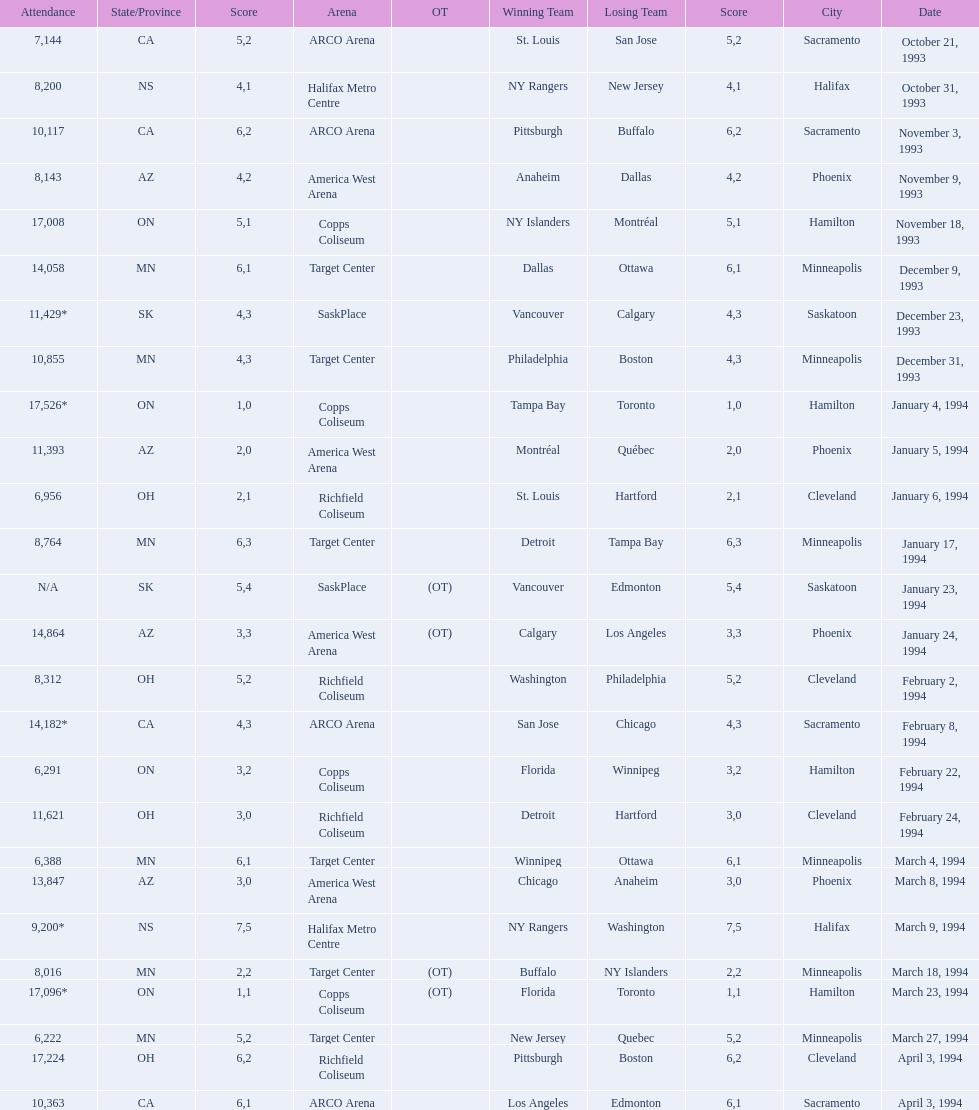Could you help me parse every detail presented in this table? {'header': ['Attendance', 'State/Province', 'Score', 'Arena', 'OT', 'Winning Team', 'Losing Team', 'Score', 'City', 'Date'], 'rows': [['7,144', 'CA', '5', 'ARCO Arena', '', 'St. Louis', 'San Jose', '2', 'Sacramento', 'October 21, 1993'], ['8,200', 'NS', '4', 'Halifax Metro Centre', '', 'NY Rangers', 'New Jersey', '1', 'Halifax', 'October 31, 1993'], ['10,117', 'CA', '6', 'ARCO Arena', '', 'Pittsburgh', 'Buffalo', '2', 'Sacramento', 'November 3, 1993'], ['8,143', 'AZ', '4', 'America West Arena', '', 'Anaheim', 'Dallas', '2', 'Phoenix', 'November 9, 1993'], ['17,008', 'ON', '5', 'Copps Coliseum', '', 'NY Islanders', 'Montréal', '1', 'Hamilton', 'November 18, 1993'], ['14,058', 'MN', '6', 'Target Center', '', 'Dallas', 'Ottawa', '1', 'Minneapolis', 'December 9, 1993'], ['11,429*', 'SK', '4', 'SaskPlace', '', 'Vancouver', 'Calgary', '3', 'Saskatoon', 'December 23, 1993'], ['10,855', 'MN', '4', 'Target Center', '', 'Philadelphia', 'Boston', '3', 'Minneapolis', 'December 31, 1993'], ['17,526*', 'ON', '1', 'Copps Coliseum', '', 'Tampa Bay', 'Toronto', '0', 'Hamilton', 'January 4, 1994'], ['11,393', 'AZ', '2', 'America West Arena', '', 'Montréal', 'Québec', '0', 'Phoenix', 'January 5, 1994'], ['6,956', 'OH', '2', 'Richfield Coliseum', '', 'St. Louis', 'Hartford', '1', 'Cleveland', 'January 6, 1994'], ['8,764', 'MN', '6', 'Target Center', '', 'Detroit', 'Tampa Bay', '3', 'Minneapolis', 'January 17, 1994'], ['N/A', 'SK', '5', 'SaskPlace', '(OT)', 'Vancouver', 'Edmonton', '4', 'Saskatoon', 'January 23, 1994'], ['14,864', 'AZ', '3', 'America West Arena', '(OT)', 'Calgary', 'Los Angeles', '3', 'Phoenix', 'January 24, 1994'], ['8,312', 'OH', '5', 'Richfield Coliseum', '', 'Washington', 'Philadelphia', '2', 'Cleveland', 'February 2, 1994'], ['14,182*', 'CA', '4', 'ARCO Arena', '', 'San Jose', 'Chicago', '3', 'Sacramento', 'February 8, 1994'], ['6,291', 'ON', '3', 'Copps Coliseum', '', 'Florida', 'Winnipeg', '2', 'Hamilton', 'February 22, 1994'], ['11,621', 'OH', '3', 'Richfield Coliseum', '', 'Detroit', 'Hartford', '0', 'Cleveland', 'February 24, 1994'], ['6,388', 'MN', '6', 'Target Center', '', 'Winnipeg', 'Ottawa', '1', 'Minneapolis', 'March 4, 1994'], ['13,847', 'AZ', '3', 'America West Arena', '', 'Chicago', 'Anaheim', '0', 'Phoenix', 'March 8, 1994'], ['9,200*', 'NS', '7', 'Halifax Metro Centre', '', 'NY Rangers', 'Washington', '5', 'Halifax', 'March 9, 1994'], ['8,016', 'MN', '2', 'Target Center', '(OT)', 'Buffalo', 'NY Islanders', '2', 'Minneapolis', 'March 18, 1994'], ['17,096*', 'ON', '1', 'Copps Coliseum', '(OT)', 'Florida', 'Toronto', '1', 'Hamilton', 'March 23, 1994'], ['6,222', 'MN', '5', 'Target Center', '', 'New Jersey', 'Quebec', '2', 'Minneapolis', 'March 27, 1994'], ['17,224', 'OH', '6', 'Richfield Coliseum', '', 'Pittsburgh', 'Boston', '2', 'Cleveland', 'April 3, 1994'], ['10,363', 'CA', '6', 'ARCO Arena', '', 'Los Angeles', 'Edmonton', '1', 'Sacramento', 'April 3, 1994']]} How many games have been held in minneapolis? 6. 